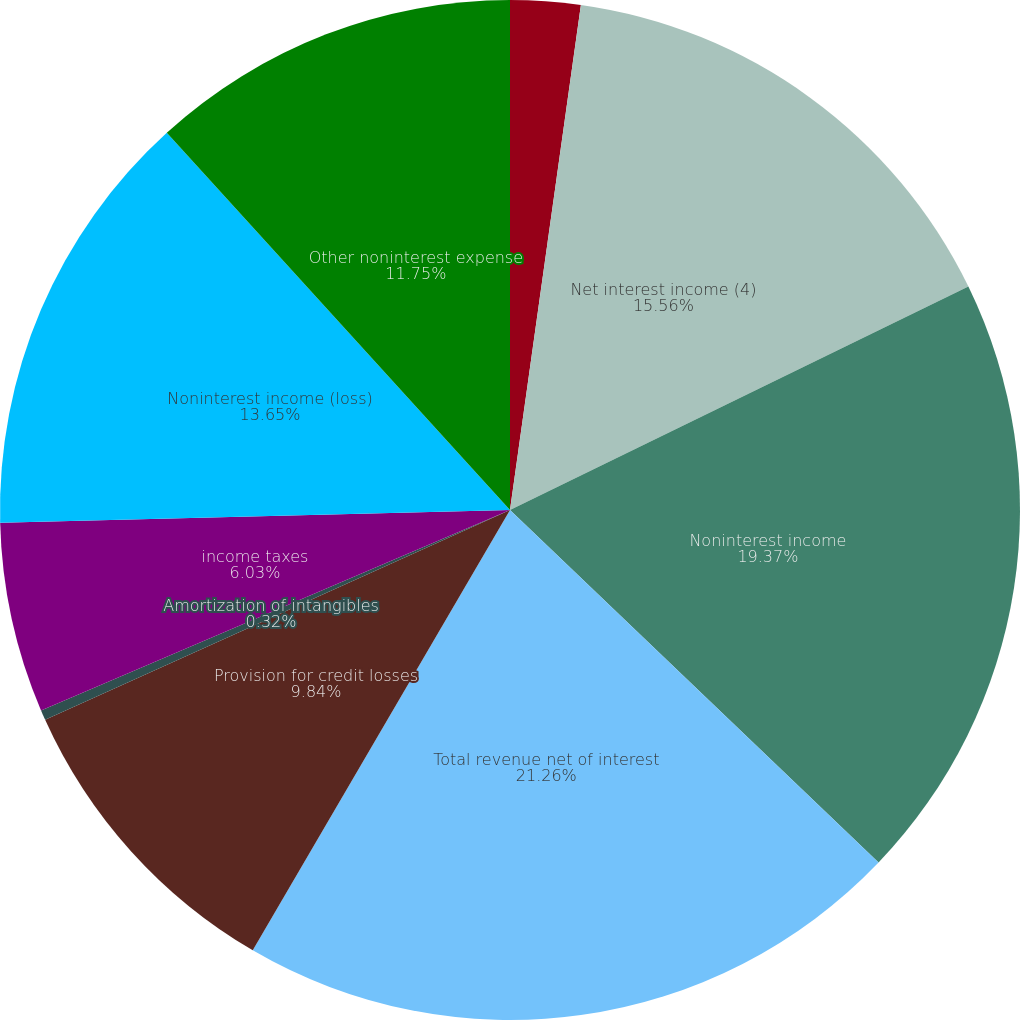Convert chart. <chart><loc_0><loc_0><loc_500><loc_500><pie_chart><fcel>(Dollars in millions)<fcel>Net interest income (4)<fcel>Noninterest income<fcel>Total revenue net of interest<fcel>Provision for credit losses<fcel>Amortization of intangibles<fcel>income taxes<fcel>Noninterest income (loss)<fcel>Other noninterest expense<nl><fcel>2.22%<fcel>15.56%<fcel>19.37%<fcel>21.27%<fcel>9.84%<fcel>0.32%<fcel>6.03%<fcel>13.65%<fcel>11.75%<nl></chart> 